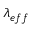<formula> <loc_0><loc_0><loc_500><loc_500>\lambda _ { e f f }</formula> 